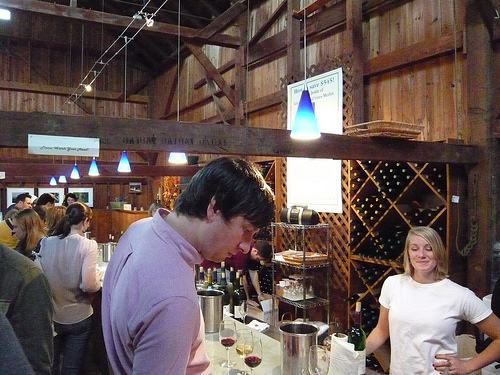<image>
Can you confirm if the man is in front of the mug? Yes. The man is positioned in front of the mug, appearing closer to the camera viewpoint. 